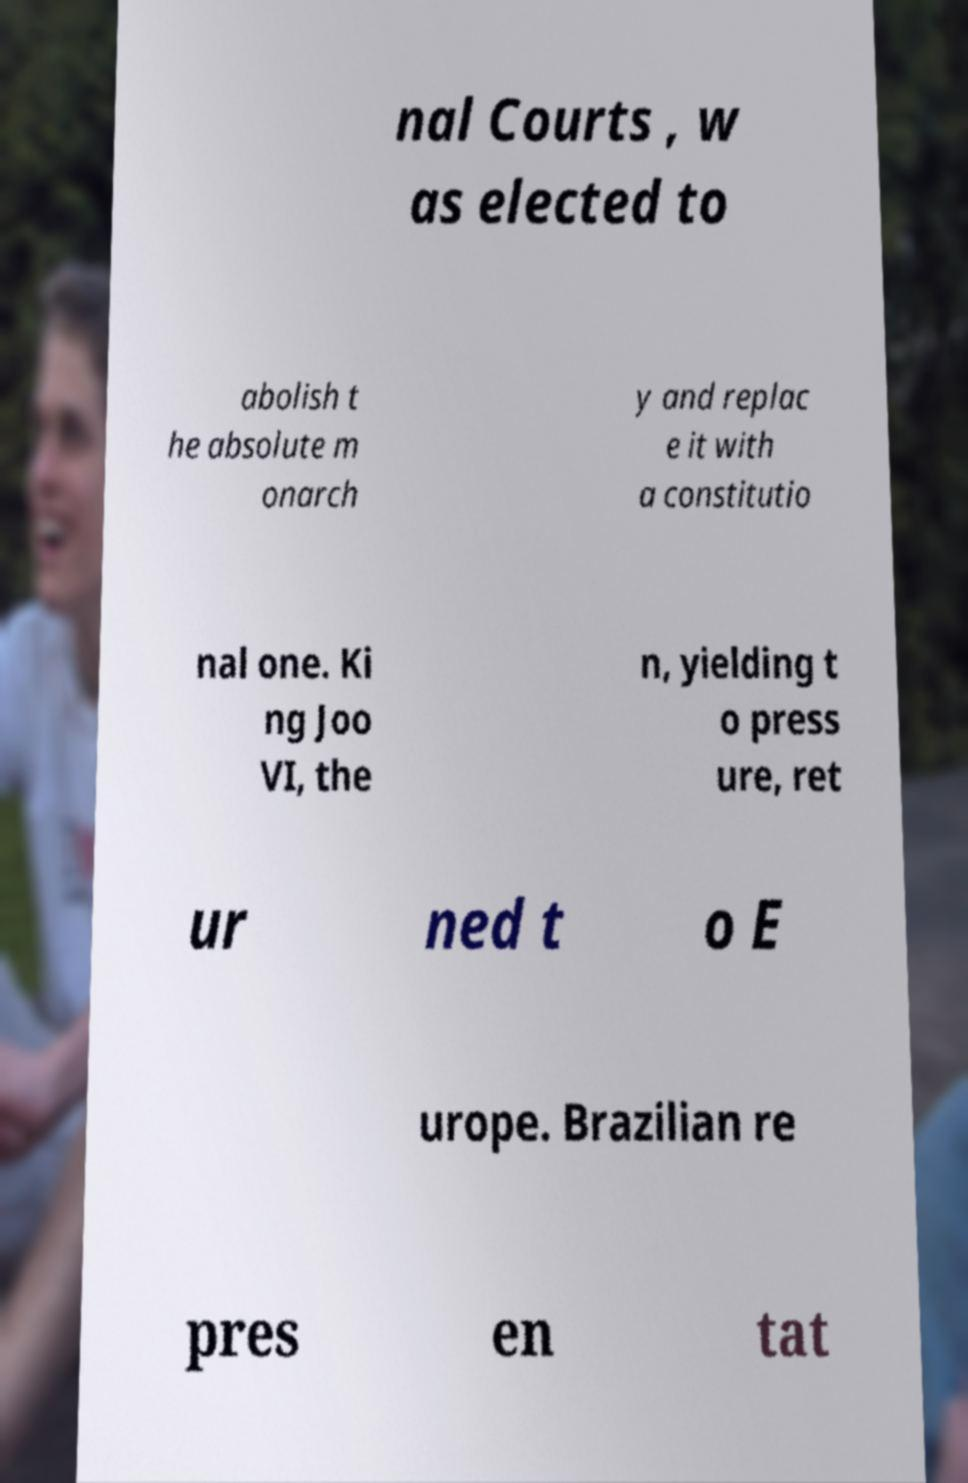I need the written content from this picture converted into text. Can you do that? nal Courts , w as elected to abolish t he absolute m onarch y and replac e it with a constitutio nal one. Ki ng Joo VI, the n, yielding t o press ure, ret ur ned t o E urope. Brazilian re pres en tat 